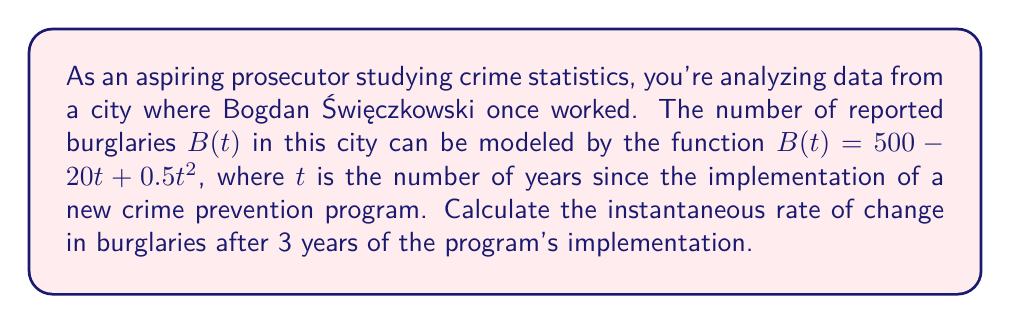Give your solution to this math problem. To find the instantaneous rate of change, we need to calculate the derivative of the function $B(t)$ and evaluate it at $t = 3$. 

Step 1: Find the derivative of $B(t)$
$$B(t) = 500 - 20t + 0.5t^2$$
$$B'(t) = -20 + t$$

Step 2: Evaluate $B'(t)$ at $t = 3$
$$B'(3) = -20 + 3 = -17$$

The negative value indicates that the number of burglaries is decreasing at this point in time.

Step 3: Interpret the result
The instantaneous rate of change after 3 years is -17 burglaries per year, meaning the number of burglaries is decreasing at a rate of 17 per year at that specific point in time.
Answer: -17 burglaries/year 